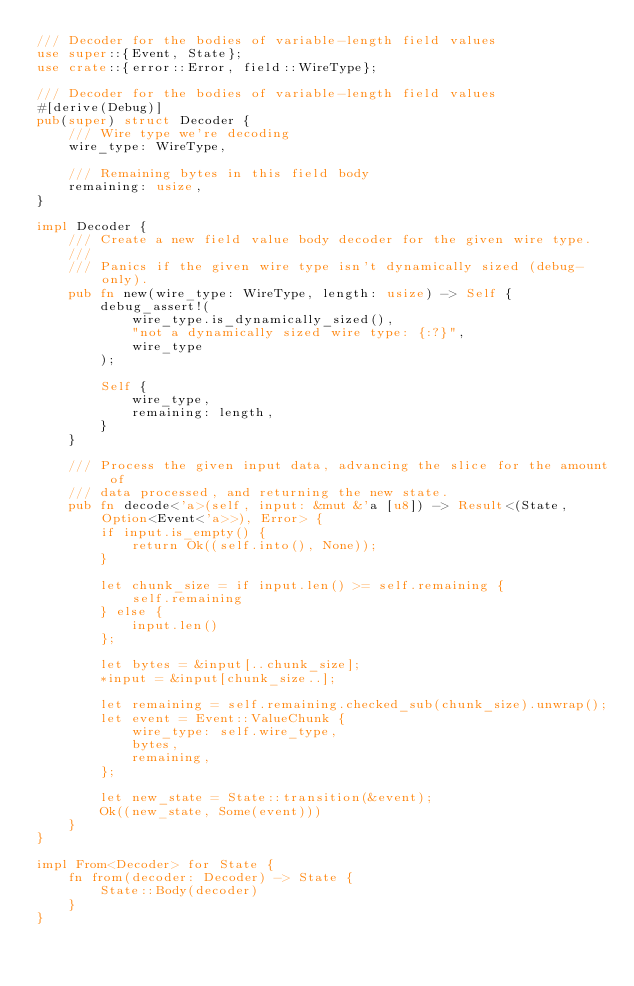Convert code to text. <code><loc_0><loc_0><loc_500><loc_500><_Rust_>/// Decoder for the bodies of variable-length field values
use super::{Event, State};
use crate::{error::Error, field::WireType};

/// Decoder for the bodies of variable-length field values
#[derive(Debug)]
pub(super) struct Decoder {
    /// Wire type we're decoding
    wire_type: WireType,

    /// Remaining bytes in this field body
    remaining: usize,
}

impl Decoder {
    /// Create a new field value body decoder for the given wire type.
    ///
    /// Panics if the given wire type isn't dynamically sized (debug-only).
    pub fn new(wire_type: WireType, length: usize) -> Self {
        debug_assert!(
            wire_type.is_dynamically_sized(),
            "not a dynamically sized wire type: {:?}",
            wire_type
        );

        Self {
            wire_type,
            remaining: length,
        }
    }

    /// Process the given input data, advancing the slice for the amount of
    /// data processed, and returning the new state.
    pub fn decode<'a>(self, input: &mut &'a [u8]) -> Result<(State, Option<Event<'a>>), Error> {
        if input.is_empty() {
            return Ok((self.into(), None));
        }

        let chunk_size = if input.len() >= self.remaining {
            self.remaining
        } else {
            input.len()
        };

        let bytes = &input[..chunk_size];
        *input = &input[chunk_size..];

        let remaining = self.remaining.checked_sub(chunk_size).unwrap();
        let event = Event::ValueChunk {
            wire_type: self.wire_type,
            bytes,
            remaining,
        };

        let new_state = State::transition(&event);
        Ok((new_state, Some(event)))
    }
}

impl From<Decoder> for State {
    fn from(decoder: Decoder) -> State {
        State::Body(decoder)
    }
}
</code> 